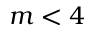Convert formula to latex. <formula><loc_0><loc_0><loc_500><loc_500>m < 4</formula> 